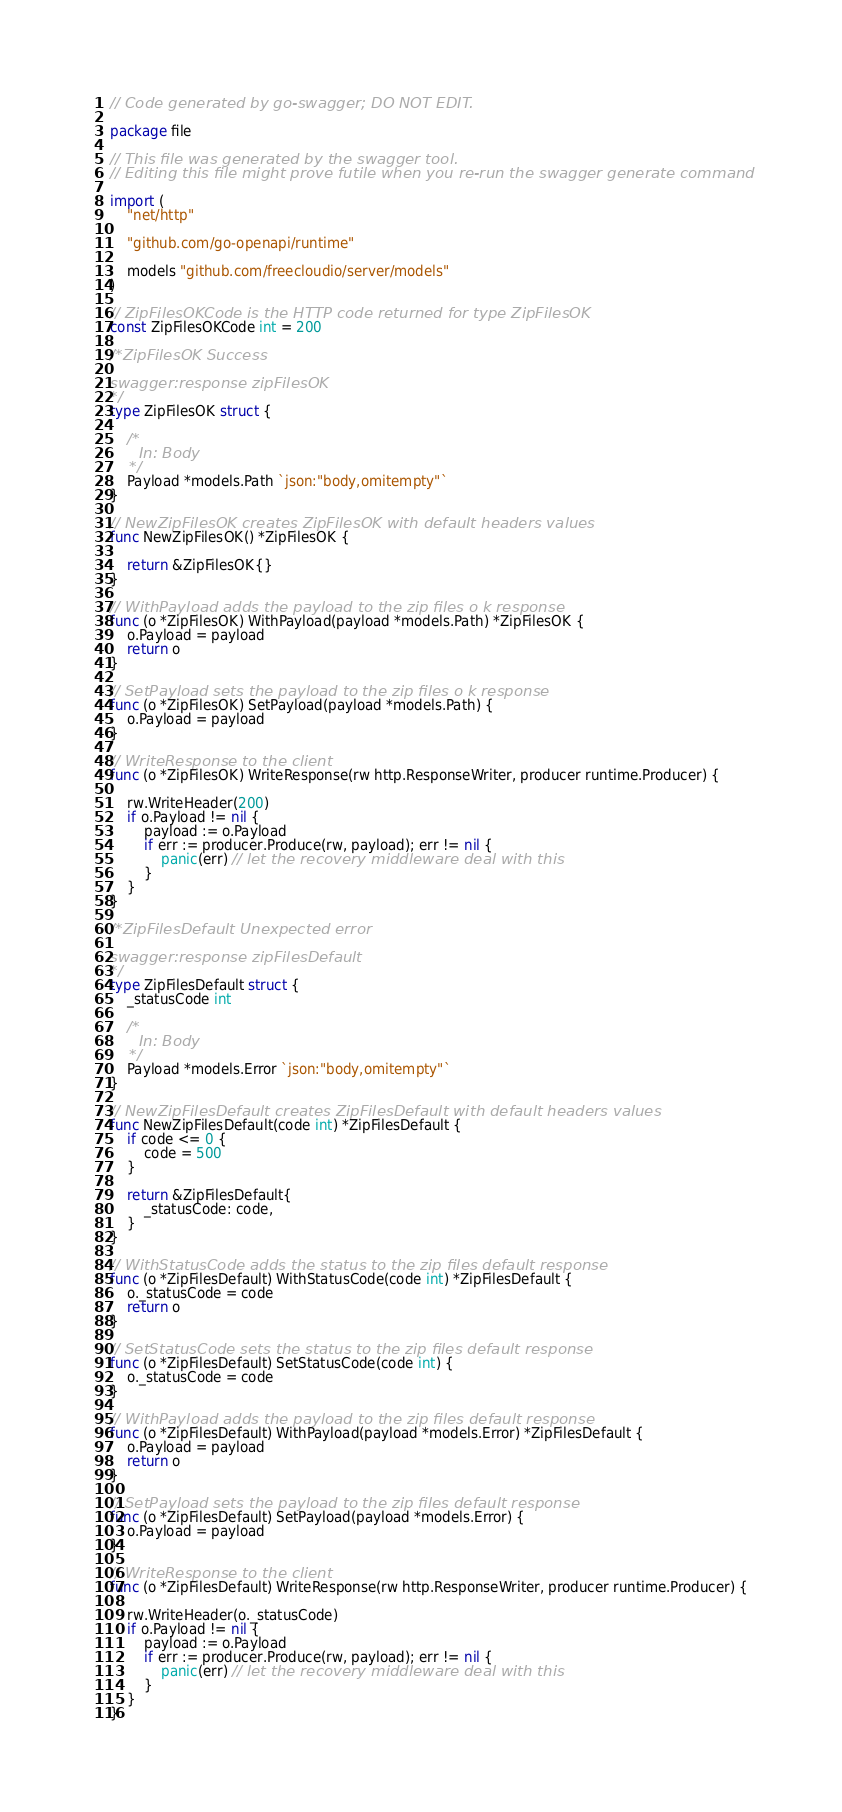<code> <loc_0><loc_0><loc_500><loc_500><_Go_>// Code generated by go-swagger; DO NOT EDIT.

package file

// This file was generated by the swagger tool.
// Editing this file might prove futile when you re-run the swagger generate command

import (
	"net/http"

	"github.com/go-openapi/runtime"

	models "github.com/freecloudio/server/models"
)

// ZipFilesOKCode is the HTTP code returned for type ZipFilesOK
const ZipFilesOKCode int = 200

/*ZipFilesOK Success

swagger:response zipFilesOK
*/
type ZipFilesOK struct {

	/*
	  In: Body
	*/
	Payload *models.Path `json:"body,omitempty"`
}

// NewZipFilesOK creates ZipFilesOK with default headers values
func NewZipFilesOK() *ZipFilesOK {

	return &ZipFilesOK{}
}

// WithPayload adds the payload to the zip files o k response
func (o *ZipFilesOK) WithPayload(payload *models.Path) *ZipFilesOK {
	o.Payload = payload
	return o
}

// SetPayload sets the payload to the zip files o k response
func (o *ZipFilesOK) SetPayload(payload *models.Path) {
	o.Payload = payload
}

// WriteResponse to the client
func (o *ZipFilesOK) WriteResponse(rw http.ResponseWriter, producer runtime.Producer) {

	rw.WriteHeader(200)
	if o.Payload != nil {
		payload := o.Payload
		if err := producer.Produce(rw, payload); err != nil {
			panic(err) // let the recovery middleware deal with this
		}
	}
}

/*ZipFilesDefault Unexpected error

swagger:response zipFilesDefault
*/
type ZipFilesDefault struct {
	_statusCode int

	/*
	  In: Body
	*/
	Payload *models.Error `json:"body,omitempty"`
}

// NewZipFilesDefault creates ZipFilesDefault with default headers values
func NewZipFilesDefault(code int) *ZipFilesDefault {
	if code <= 0 {
		code = 500
	}

	return &ZipFilesDefault{
		_statusCode: code,
	}
}

// WithStatusCode adds the status to the zip files default response
func (o *ZipFilesDefault) WithStatusCode(code int) *ZipFilesDefault {
	o._statusCode = code
	return o
}

// SetStatusCode sets the status to the zip files default response
func (o *ZipFilesDefault) SetStatusCode(code int) {
	o._statusCode = code
}

// WithPayload adds the payload to the zip files default response
func (o *ZipFilesDefault) WithPayload(payload *models.Error) *ZipFilesDefault {
	o.Payload = payload
	return o
}

// SetPayload sets the payload to the zip files default response
func (o *ZipFilesDefault) SetPayload(payload *models.Error) {
	o.Payload = payload
}

// WriteResponse to the client
func (o *ZipFilesDefault) WriteResponse(rw http.ResponseWriter, producer runtime.Producer) {

	rw.WriteHeader(o._statusCode)
	if o.Payload != nil {
		payload := o.Payload
		if err := producer.Produce(rw, payload); err != nil {
			panic(err) // let the recovery middleware deal with this
		}
	}
}
</code> 